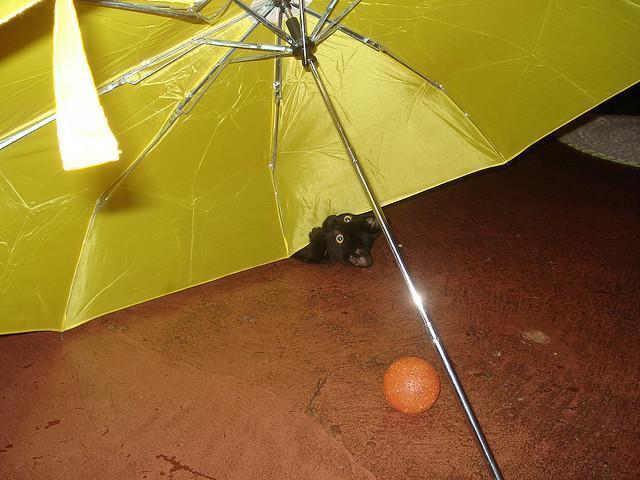How many clocks do you see?
Give a very brief answer. 0. 